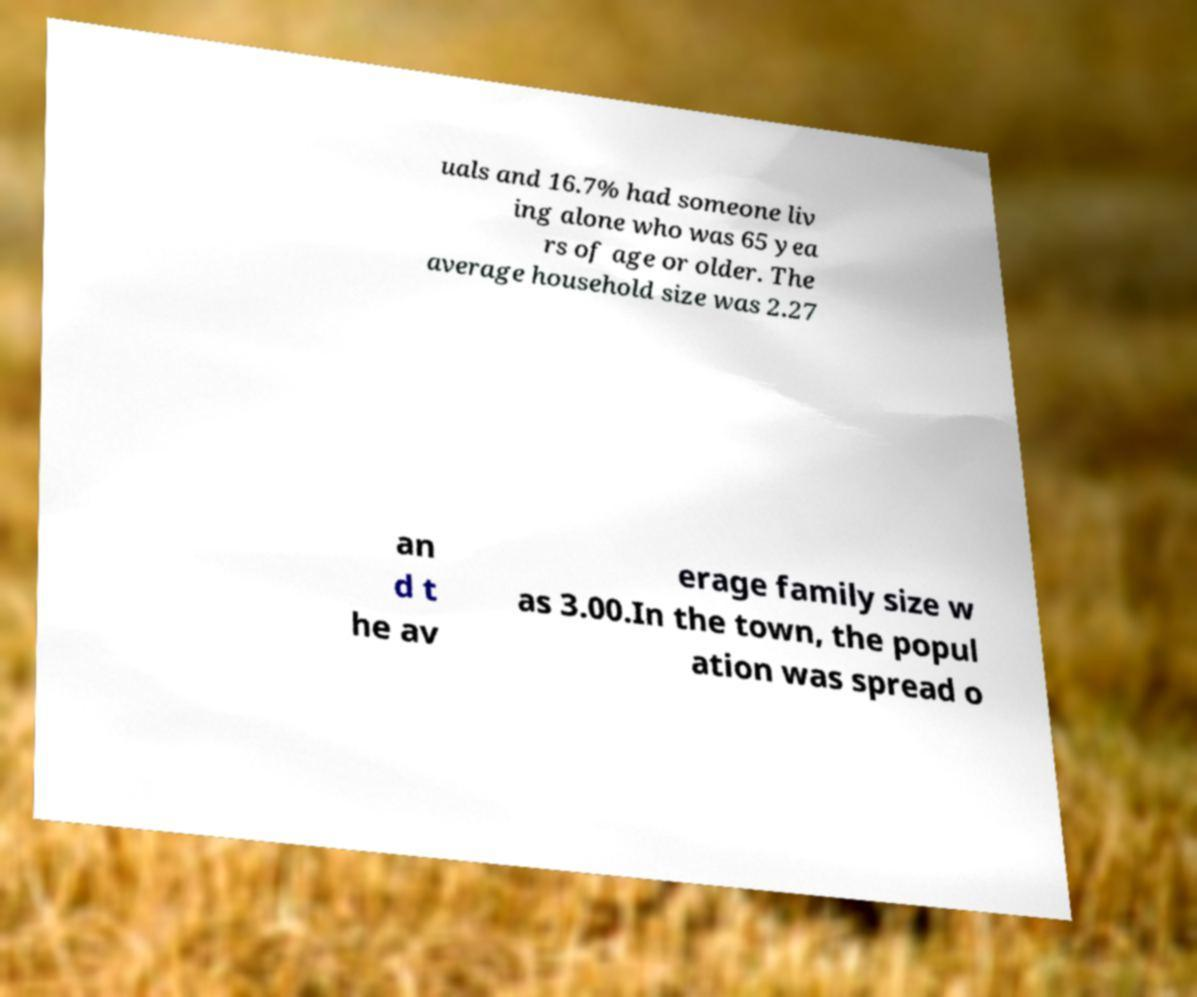I need the written content from this picture converted into text. Can you do that? uals and 16.7% had someone liv ing alone who was 65 yea rs of age or older. The average household size was 2.27 an d t he av erage family size w as 3.00.In the town, the popul ation was spread o 